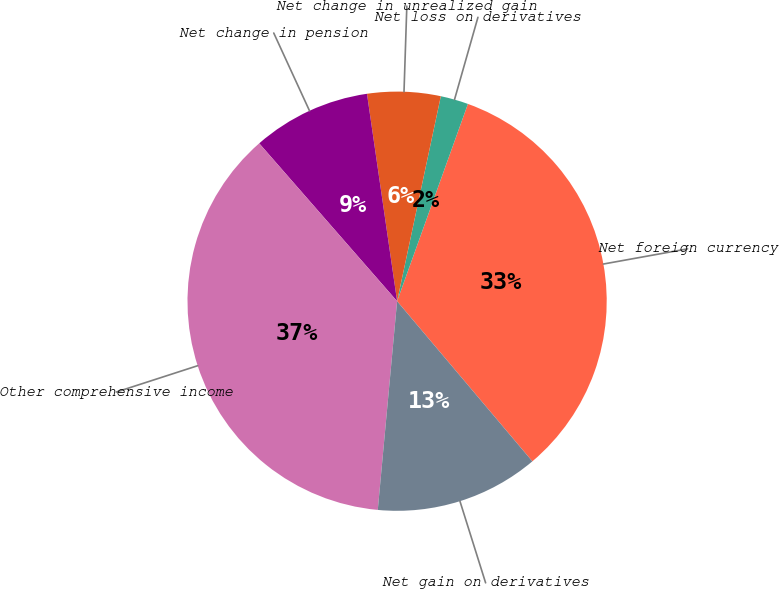Convert chart to OTSL. <chart><loc_0><loc_0><loc_500><loc_500><pie_chart><fcel>Net foreign currency<fcel>Net loss on derivatives<fcel>Net change in unrealized gain<fcel>Net change in pension<fcel>Other comprehensive income<fcel>Net gain on derivatives<nl><fcel>33.35%<fcel>2.14%<fcel>5.64%<fcel>9.13%<fcel>37.1%<fcel>12.63%<nl></chart> 